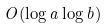<formula> <loc_0><loc_0><loc_500><loc_500>O ( \log a \log b )</formula> 